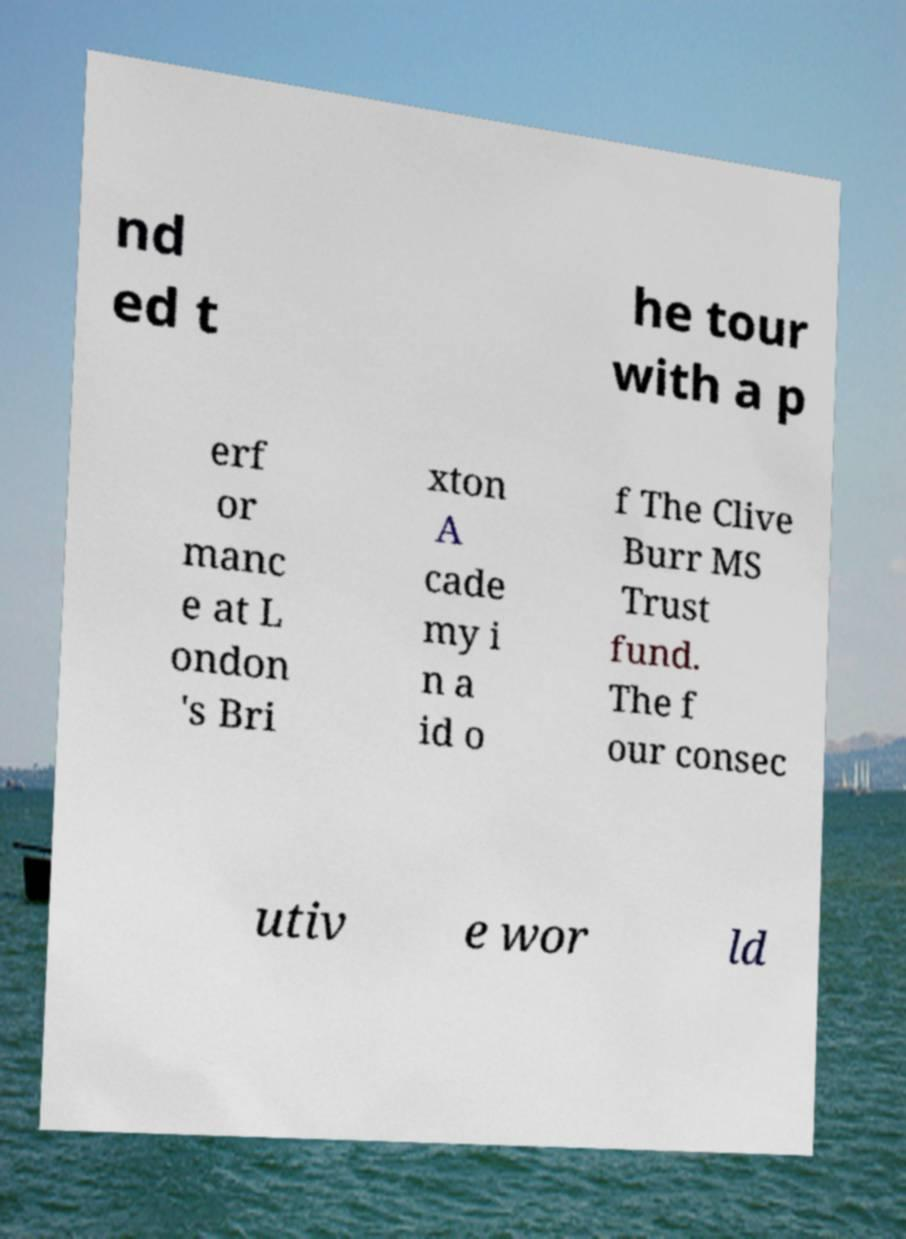Could you extract and type out the text from this image? nd ed t he tour with a p erf or manc e at L ondon 's Bri xton A cade my i n a id o f The Clive Burr MS Trust fund. The f our consec utiv e wor ld 